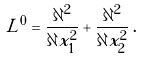<formula> <loc_0><loc_0><loc_500><loc_500>L ^ { 0 } = \frac { \partial ^ { 2 } } { \partial x ^ { 2 } _ { 1 } } + \frac { \partial ^ { 2 } } { \partial x ^ { 2 } _ { 2 } } \, .</formula> 